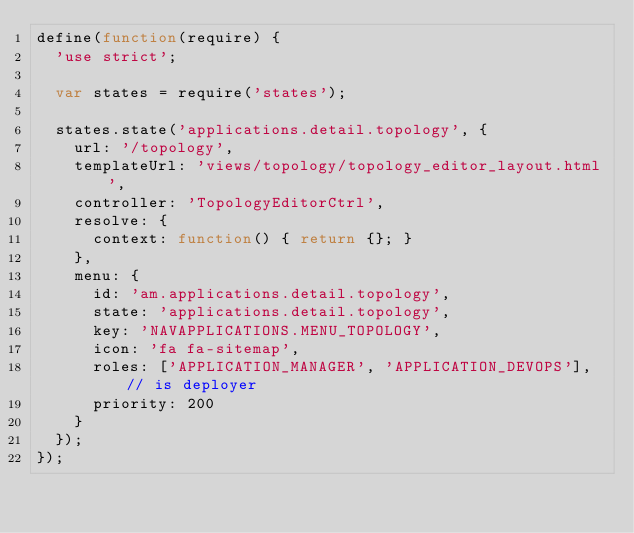Convert code to text. <code><loc_0><loc_0><loc_500><loc_500><_JavaScript_>define(function(require) {
  'use strict';

  var states = require('states');

  states.state('applications.detail.topology', {
    url: '/topology',
    templateUrl: 'views/topology/topology_editor_layout.html',
    controller: 'TopologyEditorCtrl',
    resolve: {
      context: function() { return {}; }
    },
    menu: {
      id: 'am.applications.detail.topology',
      state: 'applications.detail.topology',
      key: 'NAVAPPLICATIONS.MENU_TOPOLOGY',
      icon: 'fa fa-sitemap',
      roles: ['APPLICATION_MANAGER', 'APPLICATION_DEVOPS'], // is deployer
      priority: 200
    }
  });
});
</code> 